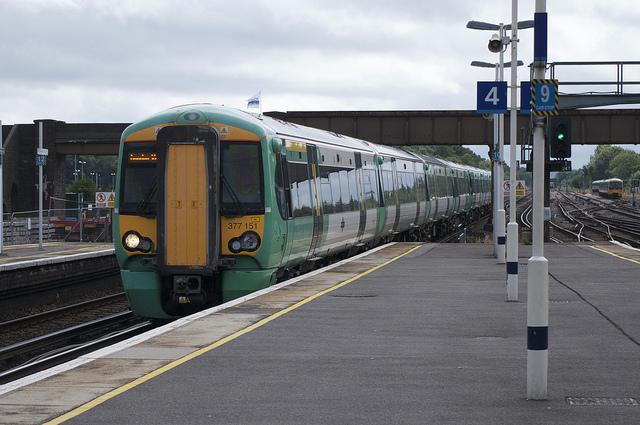Is the train moving?
Answer briefly. Yes. What is the number on the pole?
Give a very brief answer. 4. What color is the painting on the ground?
Keep it brief. Yellow. Is it cloudy?
Answer briefly. Yes. Is this a steam locomotive?
Quick response, please. No. What number is on the signpost?
Short answer required. 49. 